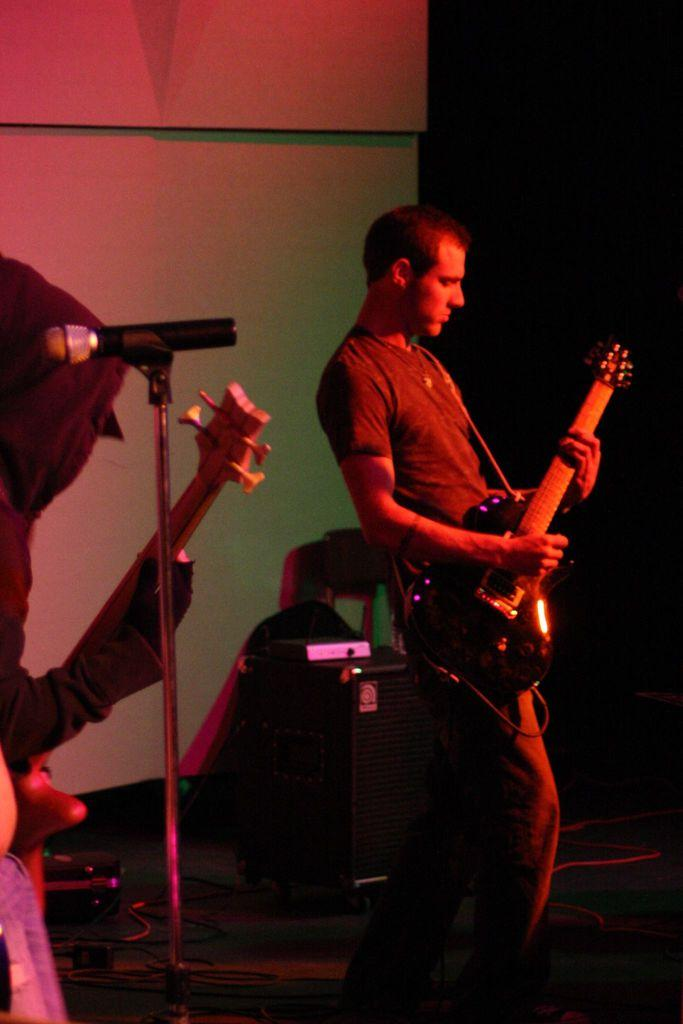What are the people in the image doing? The people in the image are playing musical instruments. What object might be used to amplify their voices or sounds? There is a microphone in the image. Can you see any ladybugs on the musical instruments in the image? There are no ladybugs present in the image. What type of stick is being used by the people playing musical instruments in the image? There is no stick visible in the image; the people are using musical instruments instead. 